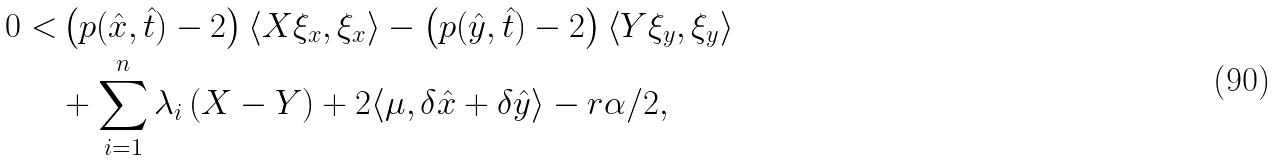Convert formula to latex. <formula><loc_0><loc_0><loc_500><loc_500>0 < & \left ( p ( \hat { x } , \hat { t } ) - 2 \right ) \left \langle X \xi _ { x } , \xi _ { x } \right \rangle - \left ( p ( \hat { y } , \hat { t } ) - 2 \right ) \left \langle Y \xi _ { y } , \xi _ { y } \right \rangle \\ & + \sum _ { i = 1 } ^ { n } \lambda _ { i } \left ( X - Y \right ) + 2 \langle \mu , \delta \hat { x } + \delta \hat { y } \rangle - r \alpha / 2 ,</formula> 